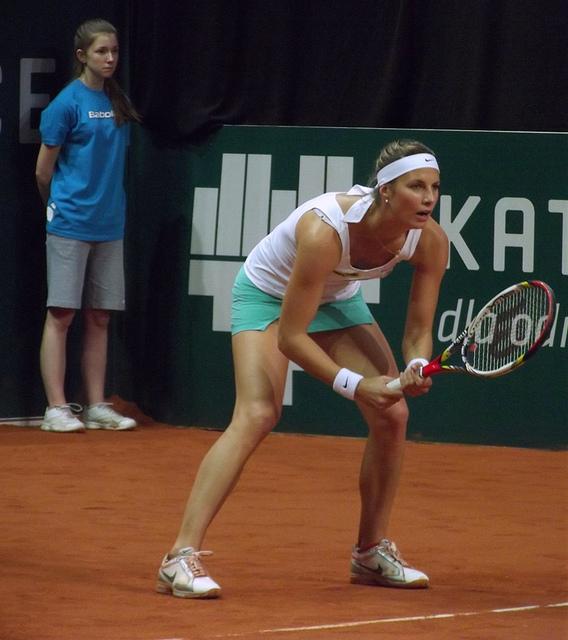Is this girl playing tennis?
Answer briefly. Yes. What brand is the racket?
Keep it brief. Wilson. What is the person in the back doing?
Concise answer only. Watching. Are these people professional athletes?
Write a very short answer. Yes. What is the large letter on the back wall?
Keep it brief. A. What color is the ground?
Answer briefly. Brown. What is written on the wall?
Answer briefly. Kat. Is the lady about to hit the ball?
Concise answer only. Yes. Is she hitting the ball?
Give a very brief answer. No. Is this person athletic?
Short answer required. Yes. What color is the woman's shirt?
Answer briefly. White. What letters are on the racquet?
Keep it brief. W. How is the woman's hair styled?
Give a very brief answer. Braid. What is the complete URL from the banner in the background?
Quick response, please. Kataorg. What brand shoe is the person wearing?
Short answer required. Nike. What color shirt is she wearing?
Be succinct. White. Is this a professional tennis player?
Be succinct. Yes. Are both feet on the ground?
Answer briefly. Yes. What is on the women's head?
Quick response, please. Headband. 